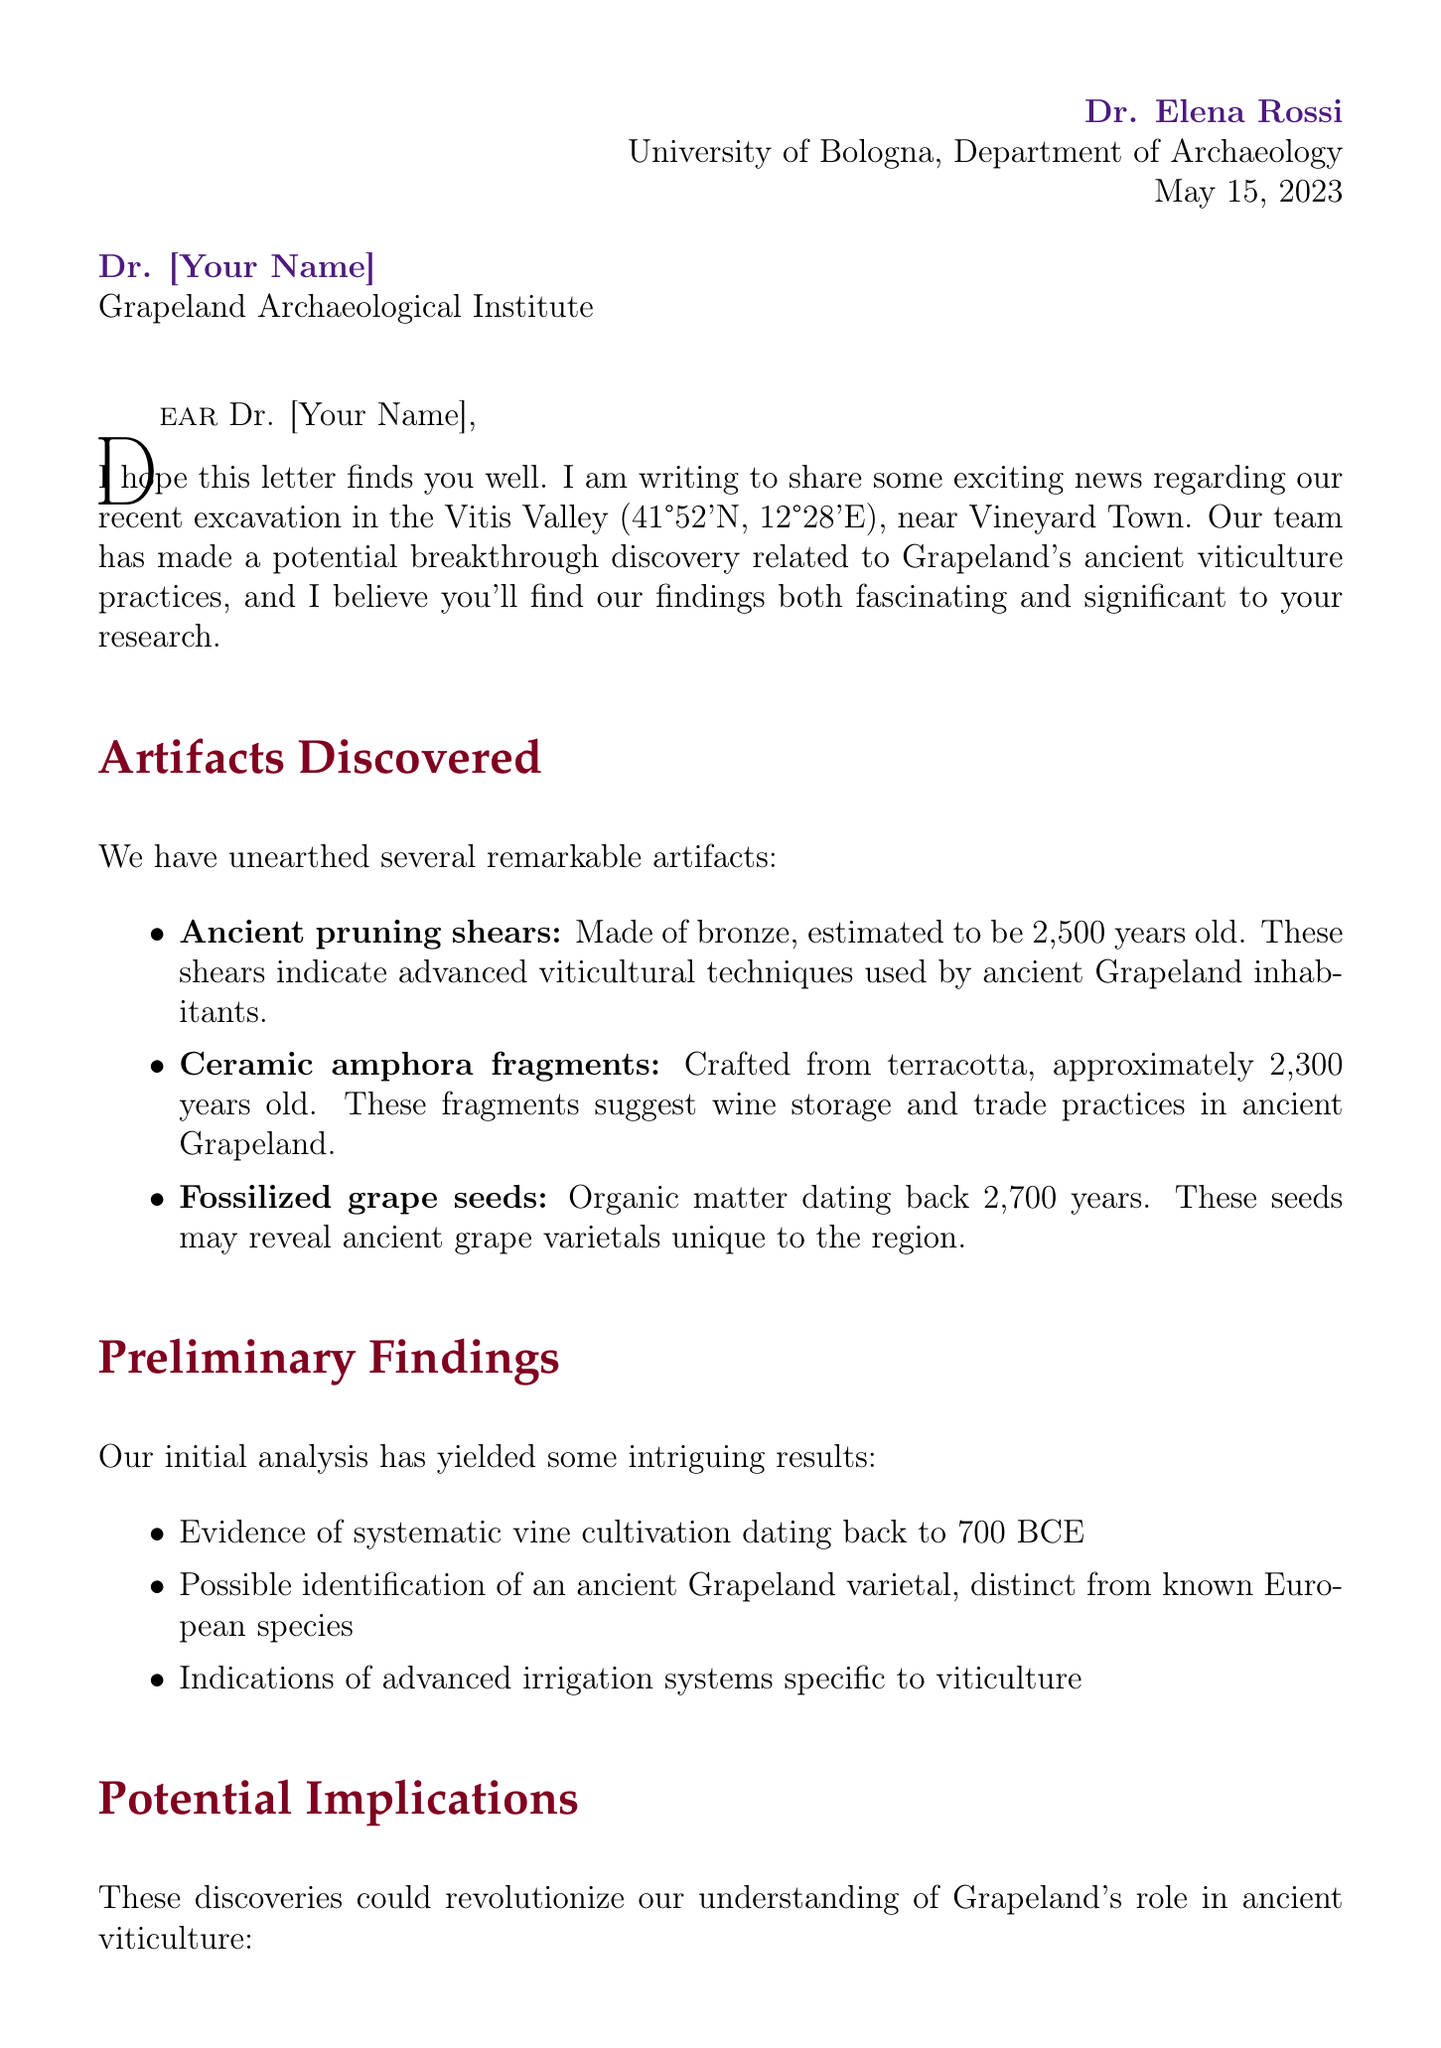What is the date of the letter? The date of the letter is mentioned at the beginning, indicating when Dr. Elena Rossi wrote to Dr. [Your Name].
Answer: May 15, 2023 Who is the sender of the letter? The sender's name is explicitly stated at the top of the letter.
Answer: Dr. Elena Rossi Where was the discovery made? The letter specifies the location of the excavation site.
Answer: Vitis Valley What is one artifact found at the site? The letter lists several artifacts discovered, any of which can be mentioned in response to this question.
Answer: Ancient pruning shears What is one proposed next step in the research? The letter outlines several next steps proposed to further research the findings.
Answer: Conduct DNA analysis on fossilized grape seeds What implications might these findings have on viticulture history? The letter discusses potential implications regarding Grapeland's role in viticulture, combining multiple points.
Answer: Early center of viticultural innovation What is one confidentiality note mentioned? The letter includes several notes on confidentiality that must be adhered to regarding the findings.
Answer: Findings not to be shared outside the research team Who is suggested for collaboration regarding paleobotany? The letter provides relevant contacts for potential collaboration, focusing on expertise related to the findings.
Answer: Dr. Marco Bianchi 